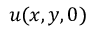<formula> <loc_0><loc_0><loc_500><loc_500>u ( x , y , 0 )</formula> 